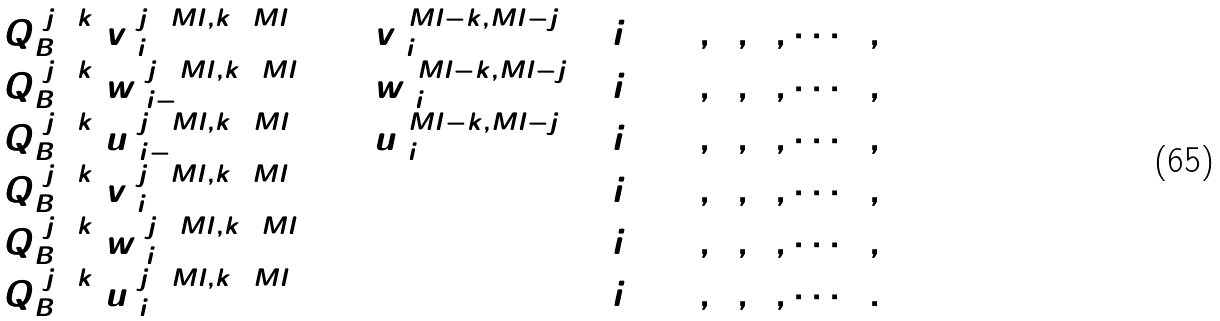Convert formula to latex. <formula><loc_0><loc_0><loc_500><loc_500>\begin{array} { l c l r } Q ^ { ( j + k ) } _ { B } v ^ { ( j + M l , k + M l ) } _ { 2 i } & = & v ^ { ( M l - k , M l - j ) } _ { 2 i + 1 } & ( i = 0 , 1 , 2 , \cdots ) \, , \\ Q ^ { ( j + k ) } _ { B } w ^ { ( j + M l , k + M l ) } _ { 2 i - 1 } & = & w ^ { ( M l - k , M l - j ) } _ { 2 i } & ( i = 1 , 2 , 3 , \cdots ) \, , \\ Q ^ { ( j + k ) } _ { B } u ^ { ( j + M l , k + M l ) } _ { 2 i - 1 } & = & u ^ { ( M l - k , M l - j ) } _ { 2 i } & ( i = 1 , 2 , 3 , \cdots ) \, , \\ Q ^ { ( j + k ) } _ { B } v ^ { ( j + M l , k + M l ) } _ { 2 i + 1 } & = & 0 & ( i = 0 , 1 , 2 , \cdots ) \, , \\ Q ^ { ( j + k ) } _ { B } w ^ { ( j + M l , k + M l ) } _ { 2 i } & = & 0 & ( i = 1 , 2 , 3 , \cdots ) \, , \\ Q ^ { ( j + k ) } _ { B } u ^ { ( j + M l , k + M l ) } _ { 2 i } & = & 0 & ( i = 1 , 2 , 3 , \cdots ) \, . \\ \end{array}</formula> 